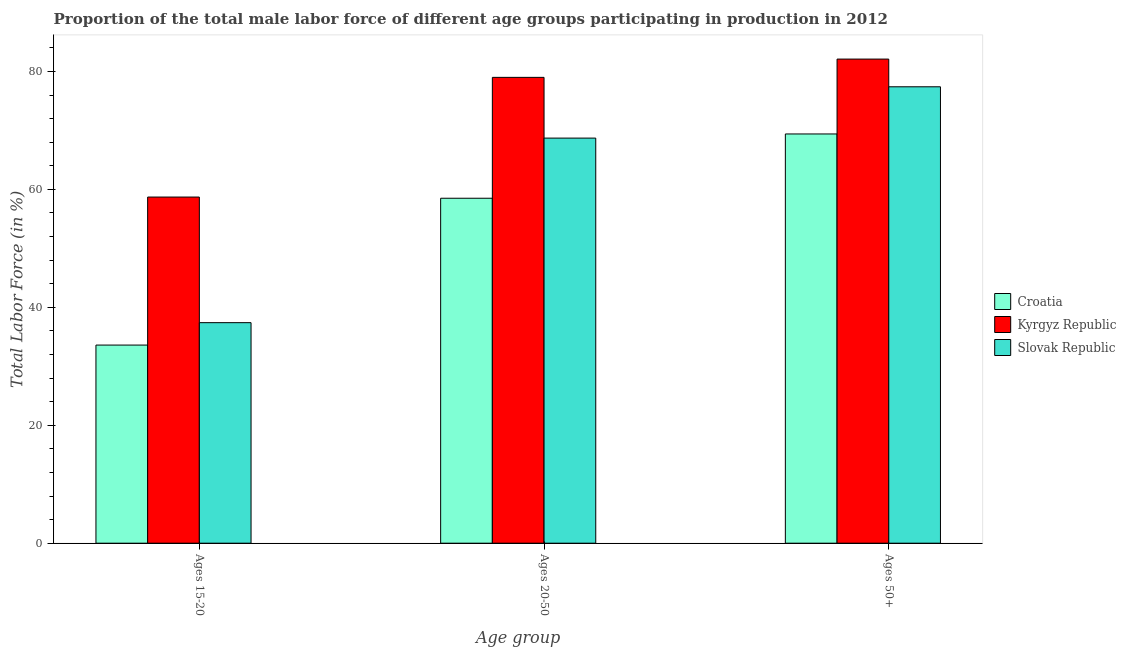How many groups of bars are there?
Offer a terse response. 3. Are the number of bars on each tick of the X-axis equal?
Make the answer very short. Yes. How many bars are there on the 2nd tick from the right?
Ensure brevity in your answer.  3. What is the label of the 2nd group of bars from the left?
Provide a succinct answer. Ages 20-50. What is the percentage of male labor force within the age group 20-50 in Kyrgyz Republic?
Ensure brevity in your answer.  79. Across all countries, what is the maximum percentage of male labor force within the age group 20-50?
Your answer should be very brief. 79. Across all countries, what is the minimum percentage of male labor force within the age group 20-50?
Your response must be concise. 58.5. In which country was the percentage of male labor force within the age group 20-50 maximum?
Offer a very short reply. Kyrgyz Republic. In which country was the percentage of male labor force within the age group 15-20 minimum?
Make the answer very short. Croatia. What is the total percentage of male labor force above age 50 in the graph?
Give a very brief answer. 228.9. What is the difference between the percentage of male labor force within the age group 20-50 in Slovak Republic and that in Kyrgyz Republic?
Provide a short and direct response. -10.3. What is the difference between the percentage of male labor force within the age group 15-20 in Slovak Republic and the percentage of male labor force within the age group 20-50 in Croatia?
Keep it short and to the point. -21.1. What is the average percentage of male labor force above age 50 per country?
Provide a succinct answer. 76.3. What is the difference between the percentage of male labor force above age 50 and percentage of male labor force within the age group 15-20 in Croatia?
Ensure brevity in your answer.  35.8. In how many countries, is the percentage of male labor force within the age group 20-50 greater than 12 %?
Make the answer very short. 3. What is the ratio of the percentage of male labor force above age 50 in Slovak Republic to that in Croatia?
Keep it short and to the point. 1.12. Is the difference between the percentage of male labor force above age 50 in Slovak Republic and Kyrgyz Republic greater than the difference between the percentage of male labor force within the age group 15-20 in Slovak Republic and Kyrgyz Republic?
Provide a succinct answer. Yes. What is the difference between the highest and the second highest percentage of male labor force above age 50?
Your answer should be compact. 4.7. What does the 2nd bar from the left in Ages 15-20 represents?
Offer a very short reply. Kyrgyz Republic. What does the 2nd bar from the right in Ages 50+ represents?
Your response must be concise. Kyrgyz Republic. How many bars are there?
Your answer should be very brief. 9. Are all the bars in the graph horizontal?
Offer a terse response. No. How many countries are there in the graph?
Make the answer very short. 3. What is the difference between two consecutive major ticks on the Y-axis?
Your answer should be very brief. 20. Are the values on the major ticks of Y-axis written in scientific E-notation?
Keep it short and to the point. No. Does the graph contain any zero values?
Provide a short and direct response. No. Does the graph contain grids?
Give a very brief answer. No. Where does the legend appear in the graph?
Your response must be concise. Center right. How many legend labels are there?
Your response must be concise. 3. How are the legend labels stacked?
Keep it short and to the point. Vertical. What is the title of the graph?
Give a very brief answer. Proportion of the total male labor force of different age groups participating in production in 2012. What is the label or title of the X-axis?
Give a very brief answer. Age group. What is the label or title of the Y-axis?
Your answer should be very brief. Total Labor Force (in %). What is the Total Labor Force (in %) in Croatia in Ages 15-20?
Your answer should be very brief. 33.6. What is the Total Labor Force (in %) in Kyrgyz Republic in Ages 15-20?
Give a very brief answer. 58.7. What is the Total Labor Force (in %) of Slovak Republic in Ages 15-20?
Ensure brevity in your answer.  37.4. What is the Total Labor Force (in %) of Croatia in Ages 20-50?
Your response must be concise. 58.5. What is the Total Labor Force (in %) of Kyrgyz Republic in Ages 20-50?
Give a very brief answer. 79. What is the Total Labor Force (in %) in Slovak Republic in Ages 20-50?
Make the answer very short. 68.7. What is the Total Labor Force (in %) of Croatia in Ages 50+?
Your response must be concise. 69.4. What is the Total Labor Force (in %) of Kyrgyz Republic in Ages 50+?
Your response must be concise. 82.1. What is the Total Labor Force (in %) in Slovak Republic in Ages 50+?
Offer a terse response. 77.4. Across all Age group, what is the maximum Total Labor Force (in %) in Croatia?
Offer a terse response. 69.4. Across all Age group, what is the maximum Total Labor Force (in %) of Kyrgyz Republic?
Give a very brief answer. 82.1. Across all Age group, what is the maximum Total Labor Force (in %) of Slovak Republic?
Provide a short and direct response. 77.4. Across all Age group, what is the minimum Total Labor Force (in %) of Croatia?
Offer a terse response. 33.6. Across all Age group, what is the minimum Total Labor Force (in %) in Kyrgyz Republic?
Ensure brevity in your answer.  58.7. Across all Age group, what is the minimum Total Labor Force (in %) in Slovak Republic?
Offer a very short reply. 37.4. What is the total Total Labor Force (in %) in Croatia in the graph?
Offer a very short reply. 161.5. What is the total Total Labor Force (in %) of Kyrgyz Republic in the graph?
Keep it short and to the point. 219.8. What is the total Total Labor Force (in %) in Slovak Republic in the graph?
Provide a short and direct response. 183.5. What is the difference between the Total Labor Force (in %) in Croatia in Ages 15-20 and that in Ages 20-50?
Your response must be concise. -24.9. What is the difference between the Total Labor Force (in %) of Kyrgyz Republic in Ages 15-20 and that in Ages 20-50?
Keep it short and to the point. -20.3. What is the difference between the Total Labor Force (in %) in Slovak Republic in Ages 15-20 and that in Ages 20-50?
Offer a terse response. -31.3. What is the difference between the Total Labor Force (in %) of Croatia in Ages 15-20 and that in Ages 50+?
Offer a terse response. -35.8. What is the difference between the Total Labor Force (in %) of Kyrgyz Republic in Ages 15-20 and that in Ages 50+?
Offer a terse response. -23.4. What is the difference between the Total Labor Force (in %) of Kyrgyz Republic in Ages 20-50 and that in Ages 50+?
Keep it short and to the point. -3.1. What is the difference between the Total Labor Force (in %) in Croatia in Ages 15-20 and the Total Labor Force (in %) in Kyrgyz Republic in Ages 20-50?
Provide a succinct answer. -45.4. What is the difference between the Total Labor Force (in %) of Croatia in Ages 15-20 and the Total Labor Force (in %) of Slovak Republic in Ages 20-50?
Ensure brevity in your answer.  -35.1. What is the difference between the Total Labor Force (in %) of Croatia in Ages 15-20 and the Total Labor Force (in %) of Kyrgyz Republic in Ages 50+?
Your answer should be very brief. -48.5. What is the difference between the Total Labor Force (in %) in Croatia in Ages 15-20 and the Total Labor Force (in %) in Slovak Republic in Ages 50+?
Your answer should be very brief. -43.8. What is the difference between the Total Labor Force (in %) of Kyrgyz Republic in Ages 15-20 and the Total Labor Force (in %) of Slovak Republic in Ages 50+?
Your answer should be compact. -18.7. What is the difference between the Total Labor Force (in %) of Croatia in Ages 20-50 and the Total Labor Force (in %) of Kyrgyz Republic in Ages 50+?
Provide a short and direct response. -23.6. What is the difference between the Total Labor Force (in %) in Croatia in Ages 20-50 and the Total Labor Force (in %) in Slovak Republic in Ages 50+?
Provide a succinct answer. -18.9. What is the difference between the Total Labor Force (in %) of Kyrgyz Republic in Ages 20-50 and the Total Labor Force (in %) of Slovak Republic in Ages 50+?
Your response must be concise. 1.6. What is the average Total Labor Force (in %) in Croatia per Age group?
Keep it short and to the point. 53.83. What is the average Total Labor Force (in %) in Kyrgyz Republic per Age group?
Provide a succinct answer. 73.27. What is the average Total Labor Force (in %) in Slovak Republic per Age group?
Offer a very short reply. 61.17. What is the difference between the Total Labor Force (in %) of Croatia and Total Labor Force (in %) of Kyrgyz Republic in Ages 15-20?
Ensure brevity in your answer.  -25.1. What is the difference between the Total Labor Force (in %) of Croatia and Total Labor Force (in %) of Slovak Republic in Ages 15-20?
Your answer should be very brief. -3.8. What is the difference between the Total Labor Force (in %) in Kyrgyz Republic and Total Labor Force (in %) in Slovak Republic in Ages 15-20?
Give a very brief answer. 21.3. What is the difference between the Total Labor Force (in %) in Croatia and Total Labor Force (in %) in Kyrgyz Republic in Ages 20-50?
Make the answer very short. -20.5. What is the difference between the Total Labor Force (in %) of Croatia and Total Labor Force (in %) of Slovak Republic in Ages 20-50?
Your response must be concise. -10.2. What is the difference between the Total Labor Force (in %) in Kyrgyz Republic and Total Labor Force (in %) in Slovak Republic in Ages 20-50?
Provide a short and direct response. 10.3. What is the difference between the Total Labor Force (in %) of Kyrgyz Republic and Total Labor Force (in %) of Slovak Republic in Ages 50+?
Offer a very short reply. 4.7. What is the ratio of the Total Labor Force (in %) in Croatia in Ages 15-20 to that in Ages 20-50?
Your answer should be very brief. 0.57. What is the ratio of the Total Labor Force (in %) in Kyrgyz Republic in Ages 15-20 to that in Ages 20-50?
Keep it short and to the point. 0.74. What is the ratio of the Total Labor Force (in %) of Slovak Republic in Ages 15-20 to that in Ages 20-50?
Offer a terse response. 0.54. What is the ratio of the Total Labor Force (in %) of Croatia in Ages 15-20 to that in Ages 50+?
Give a very brief answer. 0.48. What is the ratio of the Total Labor Force (in %) of Kyrgyz Republic in Ages 15-20 to that in Ages 50+?
Offer a terse response. 0.71. What is the ratio of the Total Labor Force (in %) in Slovak Republic in Ages 15-20 to that in Ages 50+?
Offer a very short reply. 0.48. What is the ratio of the Total Labor Force (in %) in Croatia in Ages 20-50 to that in Ages 50+?
Keep it short and to the point. 0.84. What is the ratio of the Total Labor Force (in %) in Kyrgyz Republic in Ages 20-50 to that in Ages 50+?
Offer a very short reply. 0.96. What is the ratio of the Total Labor Force (in %) of Slovak Republic in Ages 20-50 to that in Ages 50+?
Offer a very short reply. 0.89. What is the difference between the highest and the second highest Total Labor Force (in %) in Kyrgyz Republic?
Offer a terse response. 3.1. What is the difference between the highest and the lowest Total Labor Force (in %) of Croatia?
Provide a short and direct response. 35.8. What is the difference between the highest and the lowest Total Labor Force (in %) in Kyrgyz Republic?
Offer a very short reply. 23.4. 